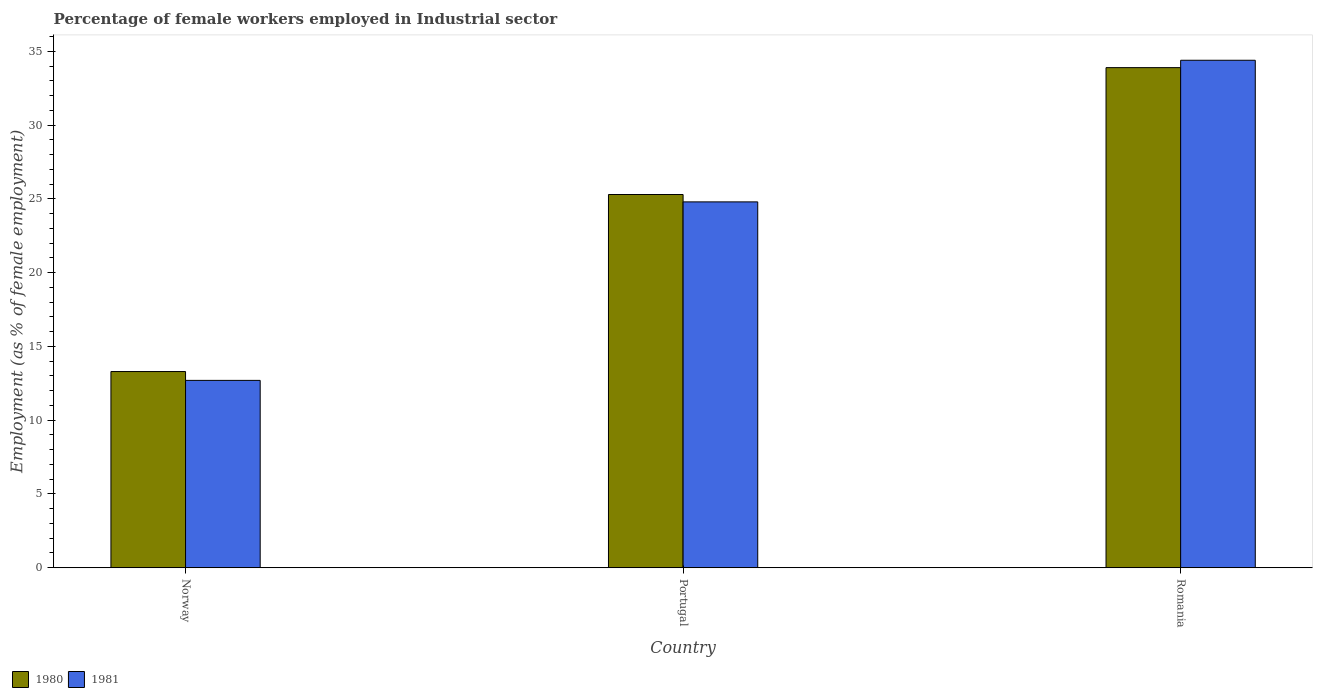How many groups of bars are there?
Your answer should be very brief. 3. Are the number of bars per tick equal to the number of legend labels?
Provide a short and direct response. Yes. Are the number of bars on each tick of the X-axis equal?
Make the answer very short. Yes. How many bars are there on the 3rd tick from the left?
Ensure brevity in your answer.  2. How many bars are there on the 3rd tick from the right?
Your answer should be very brief. 2. What is the label of the 1st group of bars from the left?
Give a very brief answer. Norway. What is the percentage of females employed in Industrial sector in 1981 in Portugal?
Provide a short and direct response. 24.8. Across all countries, what is the maximum percentage of females employed in Industrial sector in 1980?
Provide a short and direct response. 33.9. Across all countries, what is the minimum percentage of females employed in Industrial sector in 1981?
Provide a succinct answer. 12.7. In which country was the percentage of females employed in Industrial sector in 1980 maximum?
Provide a short and direct response. Romania. In which country was the percentage of females employed in Industrial sector in 1981 minimum?
Your answer should be compact. Norway. What is the total percentage of females employed in Industrial sector in 1980 in the graph?
Your answer should be compact. 72.5. What is the difference between the percentage of females employed in Industrial sector in 1980 in Portugal and that in Romania?
Make the answer very short. -8.6. What is the difference between the percentage of females employed in Industrial sector in 1981 in Portugal and the percentage of females employed in Industrial sector in 1980 in Norway?
Ensure brevity in your answer.  11.5. What is the average percentage of females employed in Industrial sector in 1981 per country?
Your response must be concise. 23.97. What is the difference between the percentage of females employed in Industrial sector of/in 1980 and percentage of females employed in Industrial sector of/in 1981 in Portugal?
Provide a succinct answer. 0.5. What is the ratio of the percentage of females employed in Industrial sector in 1980 in Norway to that in Portugal?
Keep it short and to the point. 0.53. Is the percentage of females employed in Industrial sector in 1980 in Norway less than that in Romania?
Give a very brief answer. Yes. Is the difference between the percentage of females employed in Industrial sector in 1980 in Norway and Romania greater than the difference between the percentage of females employed in Industrial sector in 1981 in Norway and Romania?
Provide a short and direct response. Yes. What is the difference between the highest and the second highest percentage of females employed in Industrial sector in 1980?
Your response must be concise. 20.6. What is the difference between the highest and the lowest percentage of females employed in Industrial sector in 1981?
Keep it short and to the point. 21.7. In how many countries, is the percentage of females employed in Industrial sector in 1980 greater than the average percentage of females employed in Industrial sector in 1980 taken over all countries?
Make the answer very short. 2. Is the sum of the percentage of females employed in Industrial sector in 1980 in Portugal and Romania greater than the maximum percentage of females employed in Industrial sector in 1981 across all countries?
Your response must be concise. Yes. How many bars are there?
Give a very brief answer. 6. How many countries are there in the graph?
Offer a terse response. 3. How are the legend labels stacked?
Offer a very short reply. Horizontal. What is the title of the graph?
Your answer should be very brief. Percentage of female workers employed in Industrial sector. What is the label or title of the X-axis?
Keep it short and to the point. Country. What is the label or title of the Y-axis?
Offer a terse response. Employment (as % of female employment). What is the Employment (as % of female employment) of 1980 in Norway?
Ensure brevity in your answer.  13.3. What is the Employment (as % of female employment) in 1981 in Norway?
Your answer should be very brief. 12.7. What is the Employment (as % of female employment) of 1980 in Portugal?
Offer a very short reply. 25.3. What is the Employment (as % of female employment) in 1981 in Portugal?
Make the answer very short. 24.8. What is the Employment (as % of female employment) in 1980 in Romania?
Ensure brevity in your answer.  33.9. What is the Employment (as % of female employment) in 1981 in Romania?
Provide a short and direct response. 34.4. Across all countries, what is the maximum Employment (as % of female employment) in 1980?
Give a very brief answer. 33.9. Across all countries, what is the maximum Employment (as % of female employment) of 1981?
Provide a short and direct response. 34.4. Across all countries, what is the minimum Employment (as % of female employment) in 1980?
Make the answer very short. 13.3. Across all countries, what is the minimum Employment (as % of female employment) in 1981?
Offer a terse response. 12.7. What is the total Employment (as % of female employment) of 1980 in the graph?
Make the answer very short. 72.5. What is the total Employment (as % of female employment) in 1981 in the graph?
Offer a terse response. 71.9. What is the difference between the Employment (as % of female employment) of 1980 in Norway and that in Portugal?
Your answer should be compact. -12. What is the difference between the Employment (as % of female employment) of 1980 in Norway and that in Romania?
Your response must be concise. -20.6. What is the difference between the Employment (as % of female employment) in 1981 in Norway and that in Romania?
Ensure brevity in your answer.  -21.7. What is the difference between the Employment (as % of female employment) of 1981 in Portugal and that in Romania?
Your response must be concise. -9.6. What is the difference between the Employment (as % of female employment) in 1980 in Norway and the Employment (as % of female employment) in 1981 in Romania?
Offer a terse response. -21.1. What is the difference between the Employment (as % of female employment) in 1980 in Portugal and the Employment (as % of female employment) in 1981 in Romania?
Ensure brevity in your answer.  -9.1. What is the average Employment (as % of female employment) in 1980 per country?
Provide a short and direct response. 24.17. What is the average Employment (as % of female employment) of 1981 per country?
Your answer should be very brief. 23.97. What is the difference between the Employment (as % of female employment) of 1980 and Employment (as % of female employment) of 1981 in Norway?
Provide a short and direct response. 0.6. What is the difference between the Employment (as % of female employment) in 1980 and Employment (as % of female employment) in 1981 in Portugal?
Provide a short and direct response. 0.5. What is the difference between the Employment (as % of female employment) of 1980 and Employment (as % of female employment) of 1981 in Romania?
Ensure brevity in your answer.  -0.5. What is the ratio of the Employment (as % of female employment) in 1980 in Norway to that in Portugal?
Provide a short and direct response. 0.53. What is the ratio of the Employment (as % of female employment) of 1981 in Norway to that in Portugal?
Your response must be concise. 0.51. What is the ratio of the Employment (as % of female employment) of 1980 in Norway to that in Romania?
Offer a very short reply. 0.39. What is the ratio of the Employment (as % of female employment) of 1981 in Norway to that in Romania?
Keep it short and to the point. 0.37. What is the ratio of the Employment (as % of female employment) in 1980 in Portugal to that in Romania?
Your answer should be compact. 0.75. What is the ratio of the Employment (as % of female employment) in 1981 in Portugal to that in Romania?
Offer a very short reply. 0.72. What is the difference between the highest and the second highest Employment (as % of female employment) in 1981?
Keep it short and to the point. 9.6. What is the difference between the highest and the lowest Employment (as % of female employment) in 1980?
Give a very brief answer. 20.6. What is the difference between the highest and the lowest Employment (as % of female employment) in 1981?
Your response must be concise. 21.7. 